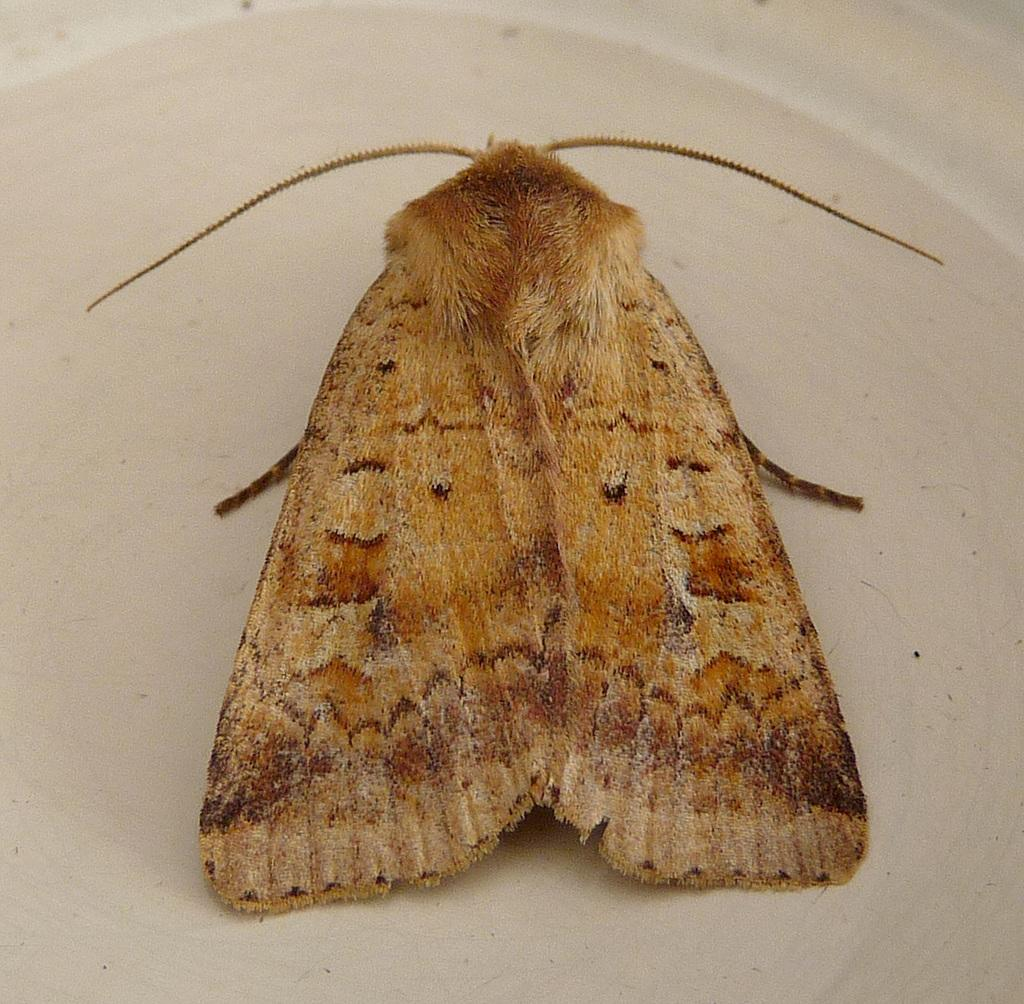What piece of furniture is present in the image? There is a table in the image. Are there any living organisms visible on the table? Yes, there is a fly on the table. How many cakes are being graded on the table in the image? There are no cakes or grading activity present in the image; it only features a table and a fly. 